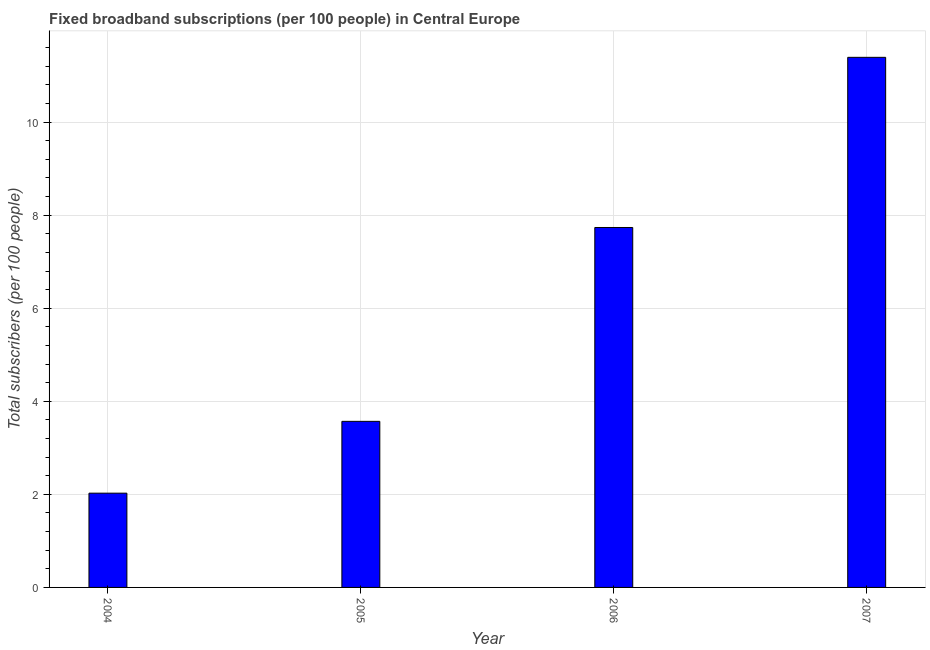Does the graph contain grids?
Keep it short and to the point. Yes. What is the title of the graph?
Make the answer very short. Fixed broadband subscriptions (per 100 people) in Central Europe. What is the label or title of the X-axis?
Keep it short and to the point. Year. What is the label or title of the Y-axis?
Your response must be concise. Total subscribers (per 100 people). What is the total number of fixed broadband subscriptions in 2004?
Keep it short and to the point. 2.03. Across all years, what is the maximum total number of fixed broadband subscriptions?
Offer a terse response. 11.39. Across all years, what is the minimum total number of fixed broadband subscriptions?
Provide a short and direct response. 2.03. What is the sum of the total number of fixed broadband subscriptions?
Your response must be concise. 24.72. What is the difference between the total number of fixed broadband subscriptions in 2004 and 2005?
Your answer should be very brief. -1.54. What is the average total number of fixed broadband subscriptions per year?
Give a very brief answer. 6.18. What is the median total number of fixed broadband subscriptions?
Give a very brief answer. 5.65. In how many years, is the total number of fixed broadband subscriptions greater than 10.8 ?
Offer a very short reply. 1. What is the ratio of the total number of fixed broadband subscriptions in 2004 to that in 2006?
Your response must be concise. 0.26. What is the difference between the highest and the second highest total number of fixed broadband subscriptions?
Keep it short and to the point. 3.66. Is the sum of the total number of fixed broadband subscriptions in 2005 and 2007 greater than the maximum total number of fixed broadband subscriptions across all years?
Ensure brevity in your answer.  Yes. What is the difference between the highest and the lowest total number of fixed broadband subscriptions?
Provide a succinct answer. 9.37. How many bars are there?
Your answer should be compact. 4. Are all the bars in the graph horizontal?
Offer a terse response. No. What is the difference between two consecutive major ticks on the Y-axis?
Ensure brevity in your answer.  2. Are the values on the major ticks of Y-axis written in scientific E-notation?
Make the answer very short. No. What is the Total subscribers (per 100 people) in 2004?
Your response must be concise. 2.03. What is the Total subscribers (per 100 people) of 2005?
Your answer should be compact. 3.57. What is the Total subscribers (per 100 people) of 2006?
Offer a very short reply. 7.73. What is the Total subscribers (per 100 people) of 2007?
Provide a succinct answer. 11.39. What is the difference between the Total subscribers (per 100 people) in 2004 and 2005?
Make the answer very short. -1.54. What is the difference between the Total subscribers (per 100 people) in 2004 and 2006?
Give a very brief answer. -5.71. What is the difference between the Total subscribers (per 100 people) in 2004 and 2007?
Your answer should be very brief. -9.37. What is the difference between the Total subscribers (per 100 people) in 2005 and 2006?
Keep it short and to the point. -4.17. What is the difference between the Total subscribers (per 100 people) in 2005 and 2007?
Offer a very short reply. -7.82. What is the difference between the Total subscribers (per 100 people) in 2006 and 2007?
Make the answer very short. -3.66. What is the ratio of the Total subscribers (per 100 people) in 2004 to that in 2005?
Give a very brief answer. 0.57. What is the ratio of the Total subscribers (per 100 people) in 2004 to that in 2006?
Provide a short and direct response. 0.26. What is the ratio of the Total subscribers (per 100 people) in 2004 to that in 2007?
Your response must be concise. 0.18. What is the ratio of the Total subscribers (per 100 people) in 2005 to that in 2006?
Provide a short and direct response. 0.46. What is the ratio of the Total subscribers (per 100 people) in 2005 to that in 2007?
Your response must be concise. 0.31. What is the ratio of the Total subscribers (per 100 people) in 2006 to that in 2007?
Give a very brief answer. 0.68. 